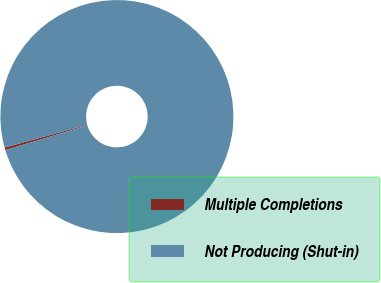<chart> <loc_0><loc_0><loc_500><loc_500><pie_chart><fcel>Multiple Completions<fcel>Not Producing (Shut-in)<nl><fcel>0.36%<fcel>99.64%<nl></chart> 